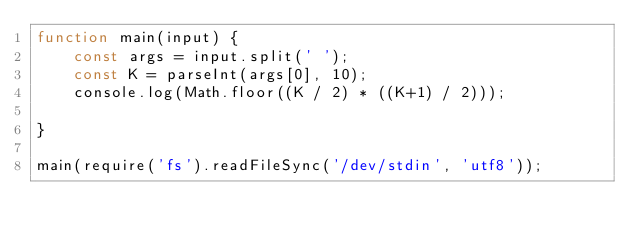Convert code to text. <code><loc_0><loc_0><loc_500><loc_500><_JavaScript_>function main(input) {
    const args = input.split(' ');
    const K = parseInt(args[0], 10);
    console.log(Math.floor((K / 2) * ((K+1) / 2)));

}

main(require('fs').readFileSync('/dev/stdin', 'utf8'));</code> 